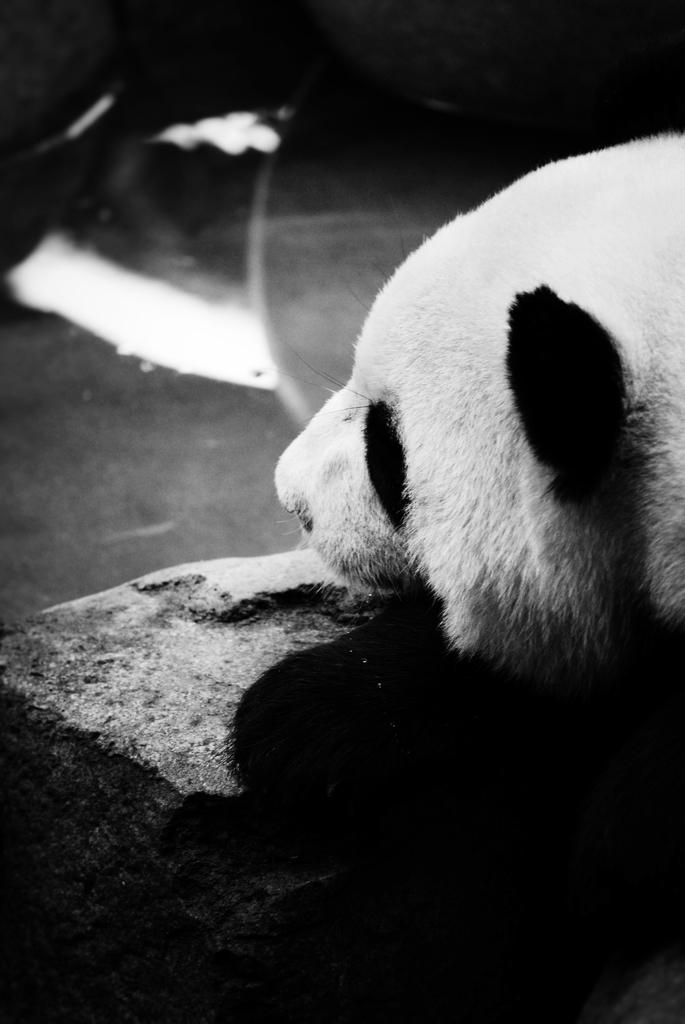What is the color scheme of the image? The image is black and white. What animal is present in the image? There is a panda in the image. What object is in front of the panda? There is a stone in front of the panda. What type of food is the panda eating in the image? There is no food present in the image; the panda is not shown eating anything. What musical instrument is the panda playing in the image? There is no musical instrument present in the image; the panda is not shown playing any instrument. 